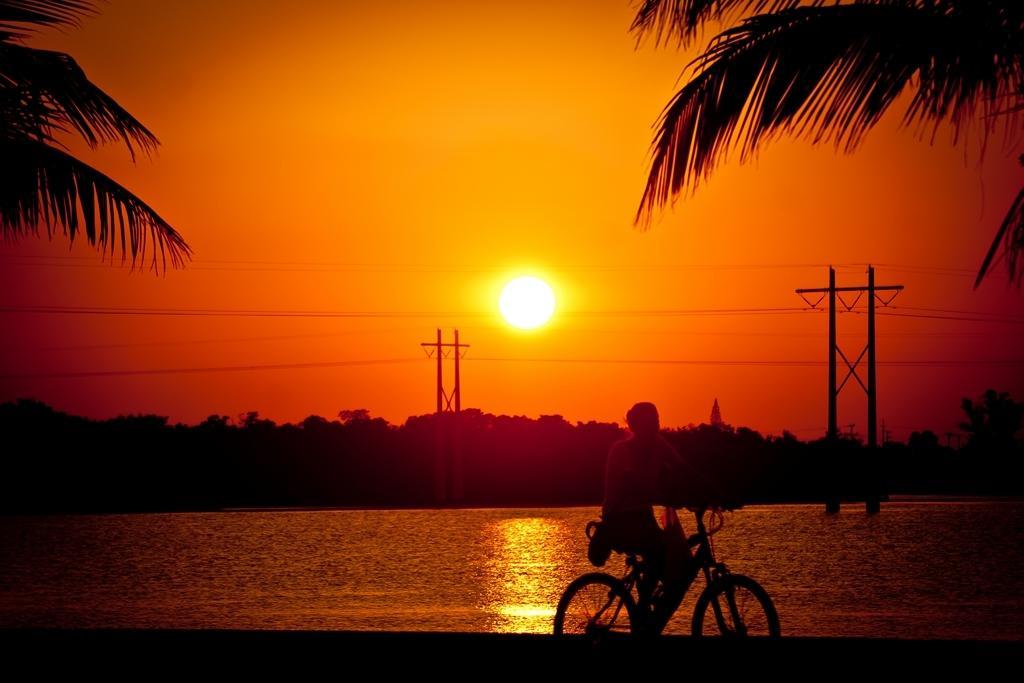Can you describe this image briefly? In this image there is a person sitting on a bicycle. Behind him there is water. There are few poles connected with wires. Background there are few trees. Top of the image there is sky, having a son. Right top there is a tree. 